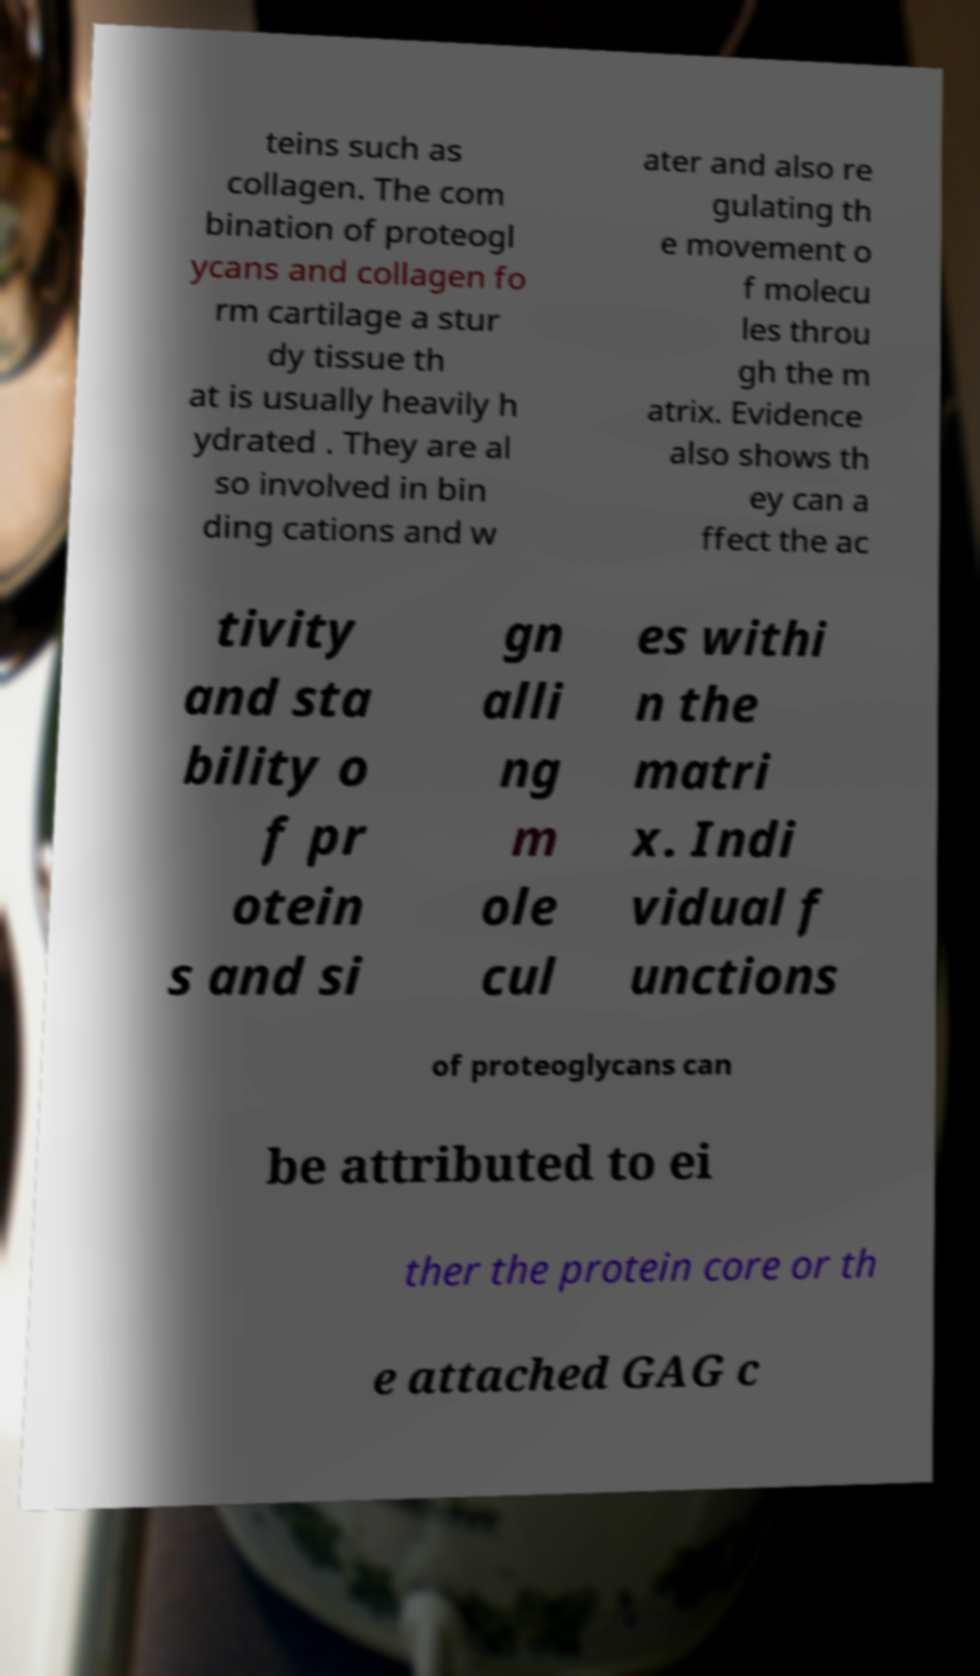For documentation purposes, I need the text within this image transcribed. Could you provide that? teins such as collagen. The com bination of proteogl ycans and collagen fo rm cartilage a stur dy tissue th at is usually heavily h ydrated . They are al so involved in bin ding cations and w ater and also re gulating th e movement o f molecu les throu gh the m atrix. Evidence also shows th ey can a ffect the ac tivity and sta bility o f pr otein s and si gn alli ng m ole cul es withi n the matri x. Indi vidual f unctions of proteoglycans can be attributed to ei ther the protein core or th e attached GAG c 